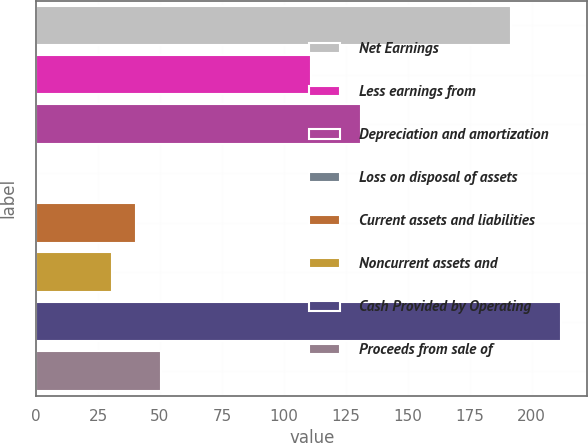Convert chart to OTSL. <chart><loc_0><loc_0><loc_500><loc_500><bar_chart><fcel>Net Earnings<fcel>Less earnings from<fcel>Depreciation and amortization<fcel>Loss on disposal of assets<fcel>Current assets and liabilities<fcel>Noncurrent assets and<fcel>Cash Provided by Operating<fcel>Proceeds from sale of<nl><fcel>191.72<fcel>111.08<fcel>131.24<fcel>0.2<fcel>40.52<fcel>30.44<fcel>211.88<fcel>50.6<nl></chart> 